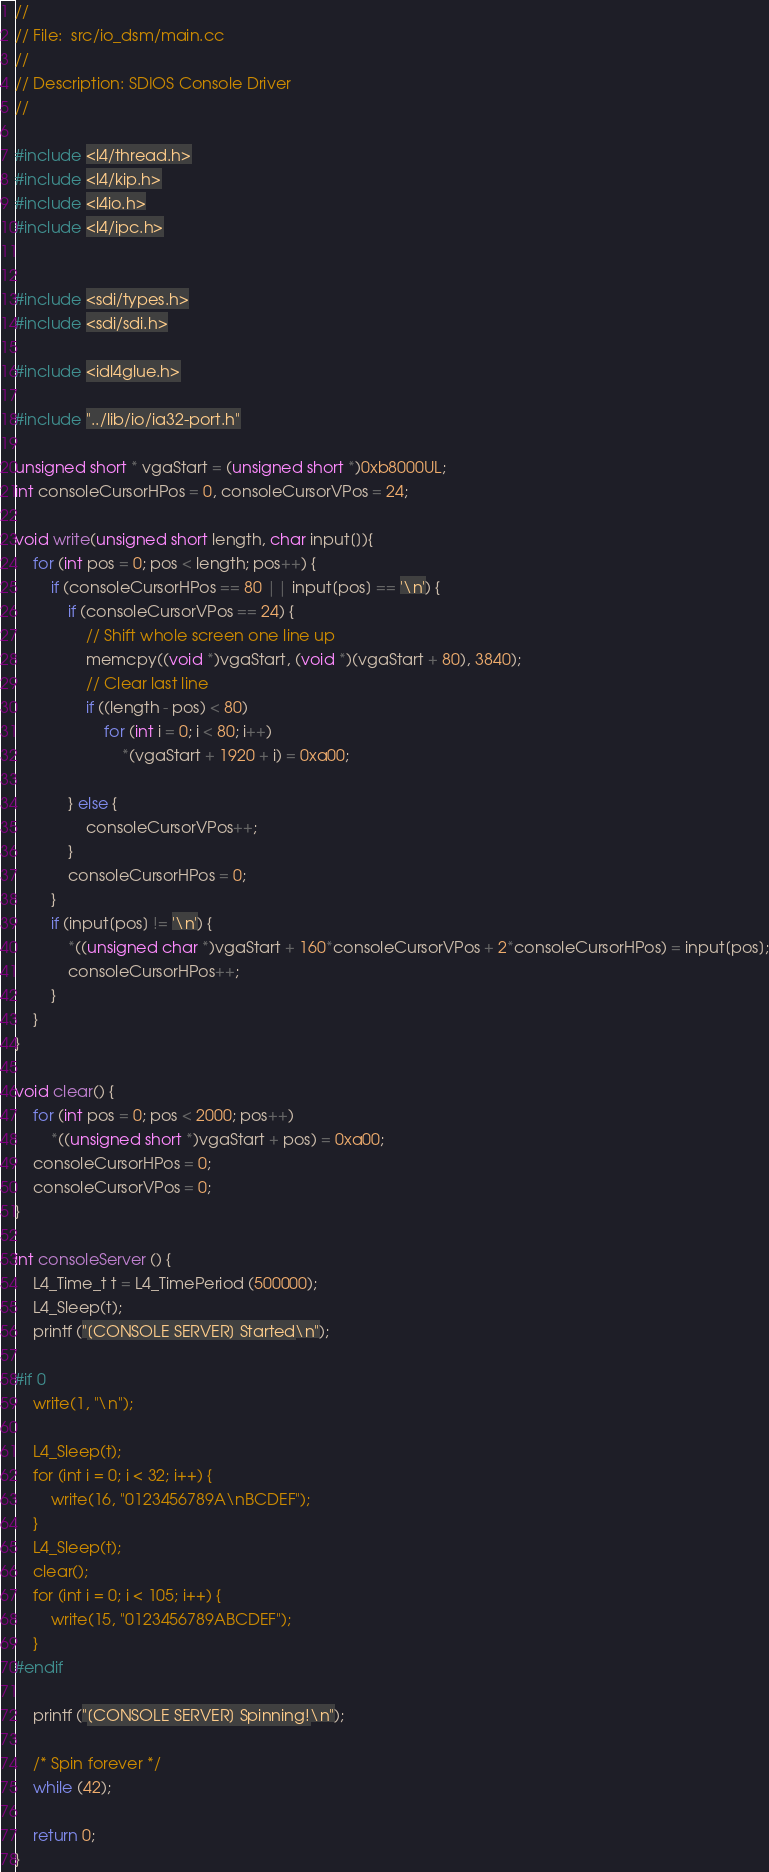Convert code to text. <code><loc_0><loc_0><loc_500><loc_500><_C++_>//
// File:  src/io_dsm/main.cc
//
// Description: SDIOS Console Driver 
//

#include <l4/thread.h>
#include <l4/kip.h>
#include <l4io.h>
#include <l4/ipc.h>


#include <sdi/types.h>
#include <sdi/sdi.h>

#include <idl4glue.h>

#include "../lib/io/ia32-port.h"

unsigned short * vgaStart = (unsigned short *)0xb8000UL;
int consoleCursorHPos = 0, consoleCursorVPos = 24;

void write(unsigned short length, char input[]){
    for (int pos = 0; pos < length; pos++) {
        if (consoleCursorHPos == 80 || input[pos] == '\n') {
            if (consoleCursorVPos == 24) {
                // Shift whole screen one line up
                memcpy((void *)vgaStart, (void *)(vgaStart + 80), 3840);
                // Clear last line
                if ((length - pos) < 80) 
                    for (int i = 0; i < 80; i++)
                        *(vgaStart + 1920 + i) = 0xa00;

            } else {
                consoleCursorVPos++;
            }
            consoleCursorHPos = 0;
        }
        if (input[pos] != '\n') {
            *((unsigned char *)vgaStart + 160*consoleCursorVPos + 2*consoleCursorHPos) = input[pos];
            consoleCursorHPos++;
        }    
    }    
}

void clear() {
    for (int pos = 0; pos < 2000; pos++)
        *((unsigned short *)vgaStart + pos) = 0xa00;
    consoleCursorHPos = 0;
    consoleCursorVPos = 0;
}

int consoleServer () {
    L4_Time_t t = L4_TimePeriod (500000);
    L4_Sleep(t);
    printf ("[CONSOLE SERVER] Started\n");

#if 0
    write(1, "\n");

    L4_Sleep(t);
    for (int i = 0; i < 32; i++) {
        write(16, "0123456789A\nBCDEF");
    }
    L4_Sleep(t);
    clear();
    for (int i = 0; i < 105; i++) {
        write(15, "0123456789ABCDEF");
    }
#endif

    printf ("[CONSOLE SERVER] Spinning!\n");
 
    /* Spin forever */
    while (42);
    
    return 0;
}
</code> 